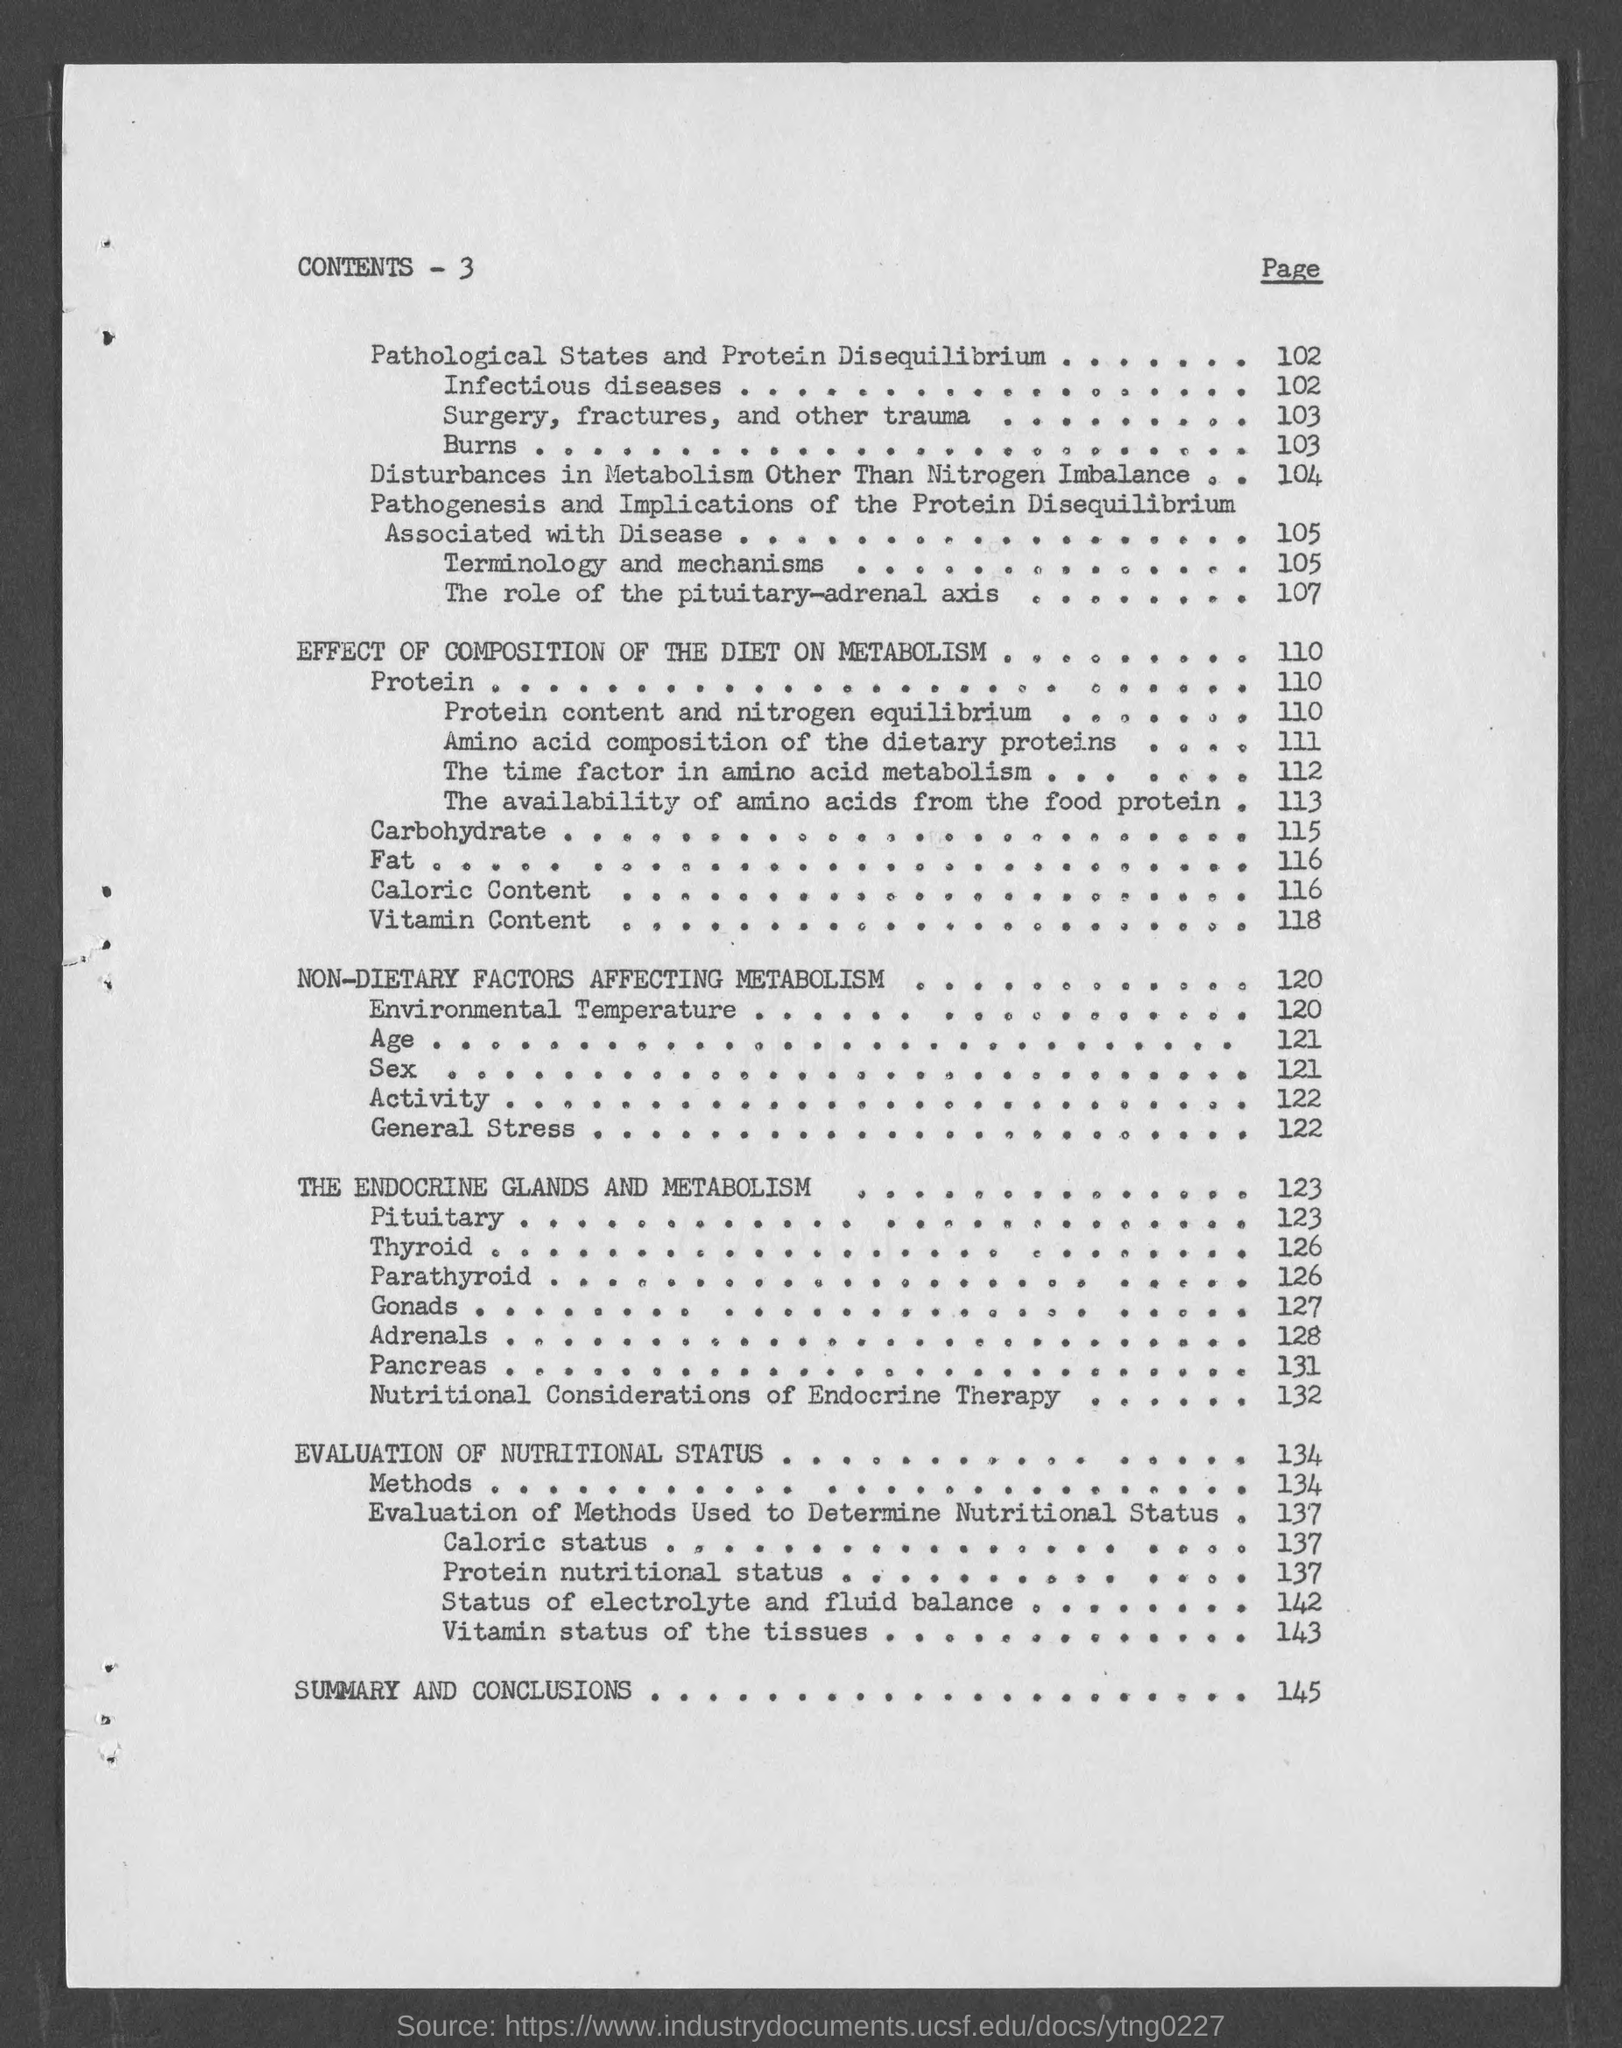What is the heading of the page ?
Provide a succinct answer. Contents - 3. What is the page number for effect of composition of the diet on metabolism ?
Provide a succinct answer. 110. What is the page no. for non- dietary factors affecting metabolism ?
Offer a terse response. 120. What is the page number for environmental temperature ?
Provide a succinct answer. 120. What is the page number for sex ?
Offer a very short reply. 121. What is the page number for the endocrine glands and metabolism ?
Your answer should be very brief. 123. What is the page number for pancreas ?
Ensure brevity in your answer.  131. What is the page number for adrenals ?
Make the answer very short. 128. 